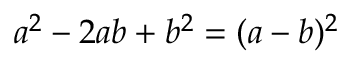Convert formula to latex. <formula><loc_0><loc_0><loc_500><loc_500>a ^ { 2 } - 2 a b + b ^ { 2 } = ( a - b ) ^ { 2 }</formula> 